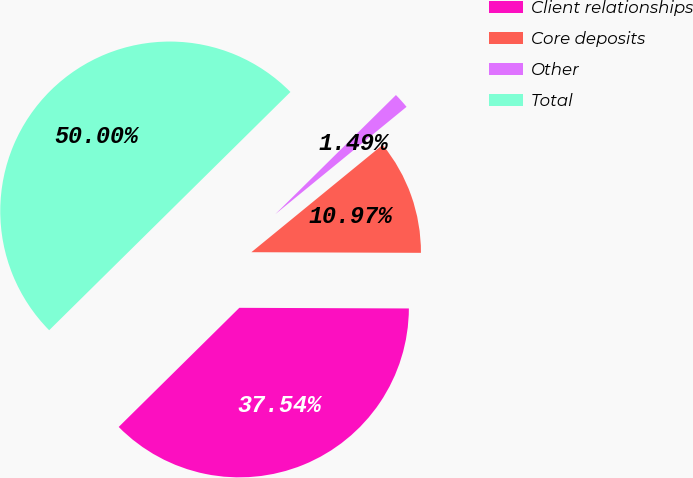Convert chart to OTSL. <chart><loc_0><loc_0><loc_500><loc_500><pie_chart><fcel>Client relationships<fcel>Core deposits<fcel>Other<fcel>Total<nl><fcel>37.54%<fcel>10.97%<fcel>1.49%<fcel>50.0%<nl></chart> 